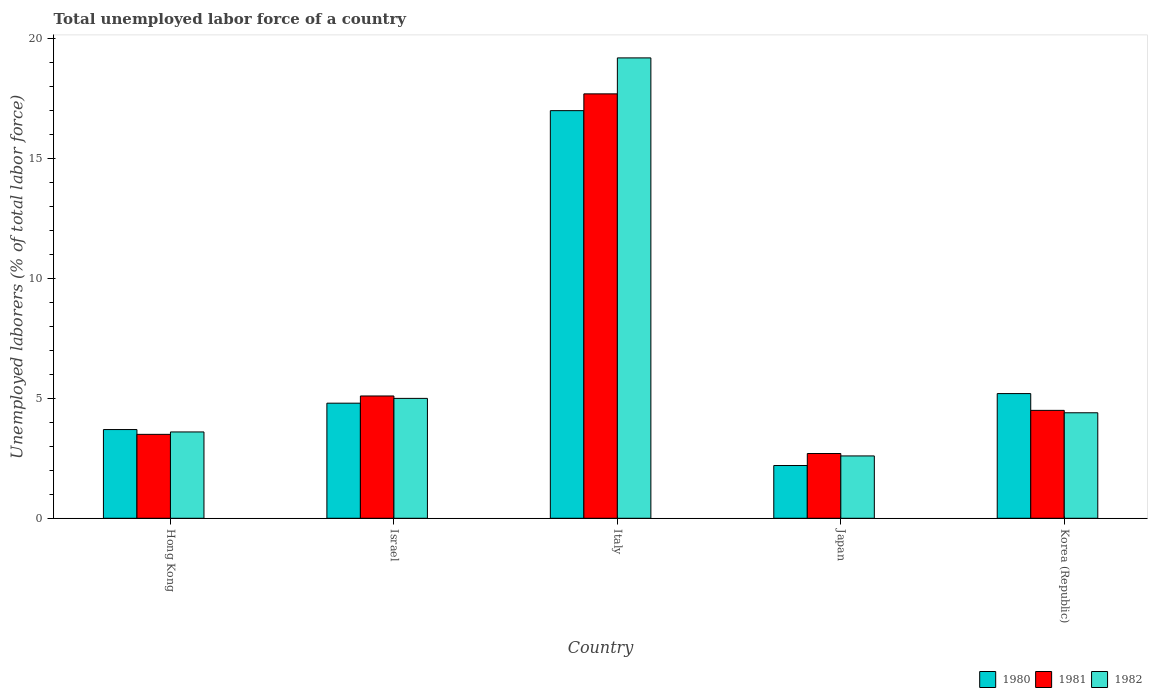How many bars are there on the 4th tick from the left?
Offer a terse response. 3. How many bars are there on the 3rd tick from the right?
Make the answer very short. 3. What is the label of the 2nd group of bars from the left?
Give a very brief answer. Israel. What is the total unemployed labor force in 1982 in Hong Kong?
Offer a very short reply. 3.6. Across all countries, what is the minimum total unemployed labor force in 1980?
Your answer should be very brief. 2.2. In which country was the total unemployed labor force in 1981 maximum?
Your response must be concise. Italy. In which country was the total unemployed labor force in 1980 minimum?
Ensure brevity in your answer.  Japan. What is the total total unemployed labor force in 1980 in the graph?
Give a very brief answer. 32.9. What is the difference between the total unemployed labor force in 1982 in Italy and that in Korea (Republic)?
Your answer should be compact. 14.8. What is the difference between the total unemployed labor force in 1982 in Japan and the total unemployed labor force in 1981 in Italy?
Provide a short and direct response. -15.1. What is the average total unemployed labor force in 1981 per country?
Offer a terse response. 6.7. What is the difference between the total unemployed labor force of/in 1982 and total unemployed labor force of/in 1980 in Israel?
Offer a very short reply. 0.2. In how many countries, is the total unemployed labor force in 1980 greater than 10 %?
Ensure brevity in your answer.  1. What is the ratio of the total unemployed labor force in 1980 in Italy to that in Korea (Republic)?
Offer a terse response. 3.27. Is the total unemployed labor force in 1982 in Japan less than that in Korea (Republic)?
Provide a short and direct response. Yes. Is the difference between the total unemployed labor force in 1982 in Japan and Korea (Republic) greater than the difference between the total unemployed labor force in 1980 in Japan and Korea (Republic)?
Give a very brief answer. Yes. What is the difference between the highest and the second highest total unemployed labor force in 1980?
Your response must be concise. 12.2. What is the difference between the highest and the lowest total unemployed labor force in 1981?
Make the answer very short. 15. In how many countries, is the total unemployed labor force in 1982 greater than the average total unemployed labor force in 1982 taken over all countries?
Offer a terse response. 1. Is it the case that in every country, the sum of the total unemployed labor force in 1981 and total unemployed labor force in 1980 is greater than the total unemployed labor force in 1982?
Your answer should be compact. Yes. Are all the bars in the graph horizontal?
Your answer should be compact. No. How many countries are there in the graph?
Make the answer very short. 5. Does the graph contain any zero values?
Provide a short and direct response. No. Does the graph contain grids?
Your answer should be very brief. No. Where does the legend appear in the graph?
Provide a short and direct response. Bottom right. What is the title of the graph?
Ensure brevity in your answer.  Total unemployed labor force of a country. What is the label or title of the X-axis?
Offer a terse response. Country. What is the label or title of the Y-axis?
Provide a succinct answer. Unemployed laborers (% of total labor force). What is the Unemployed laborers (% of total labor force) of 1980 in Hong Kong?
Ensure brevity in your answer.  3.7. What is the Unemployed laborers (% of total labor force) in 1981 in Hong Kong?
Provide a short and direct response. 3.5. What is the Unemployed laborers (% of total labor force) of 1982 in Hong Kong?
Your answer should be compact. 3.6. What is the Unemployed laborers (% of total labor force) in 1980 in Israel?
Offer a terse response. 4.8. What is the Unemployed laborers (% of total labor force) in 1981 in Israel?
Your answer should be compact. 5.1. What is the Unemployed laborers (% of total labor force) of 1980 in Italy?
Provide a short and direct response. 17. What is the Unemployed laborers (% of total labor force) in 1981 in Italy?
Provide a short and direct response. 17.7. What is the Unemployed laborers (% of total labor force) in 1982 in Italy?
Your response must be concise. 19.2. What is the Unemployed laborers (% of total labor force) in 1980 in Japan?
Provide a short and direct response. 2.2. What is the Unemployed laborers (% of total labor force) of 1981 in Japan?
Your response must be concise. 2.7. What is the Unemployed laborers (% of total labor force) in 1982 in Japan?
Make the answer very short. 2.6. What is the Unemployed laborers (% of total labor force) of 1980 in Korea (Republic)?
Offer a terse response. 5.2. What is the Unemployed laborers (% of total labor force) of 1982 in Korea (Republic)?
Your response must be concise. 4.4. Across all countries, what is the maximum Unemployed laborers (% of total labor force) in 1981?
Keep it short and to the point. 17.7. Across all countries, what is the maximum Unemployed laborers (% of total labor force) in 1982?
Provide a short and direct response. 19.2. Across all countries, what is the minimum Unemployed laborers (% of total labor force) of 1980?
Provide a succinct answer. 2.2. Across all countries, what is the minimum Unemployed laborers (% of total labor force) in 1981?
Keep it short and to the point. 2.7. Across all countries, what is the minimum Unemployed laborers (% of total labor force) of 1982?
Keep it short and to the point. 2.6. What is the total Unemployed laborers (% of total labor force) in 1980 in the graph?
Your answer should be compact. 32.9. What is the total Unemployed laborers (% of total labor force) of 1981 in the graph?
Keep it short and to the point. 33.5. What is the total Unemployed laborers (% of total labor force) of 1982 in the graph?
Make the answer very short. 34.8. What is the difference between the Unemployed laborers (% of total labor force) in 1981 in Hong Kong and that in Israel?
Give a very brief answer. -1.6. What is the difference between the Unemployed laborers (% of total labor force) of 1982 in Hong Kong and that in Israel?
Provide a succinct answer. -1.4. What is the difference between the Unemployed laborers (% of total labor force) in 1980 in Hong Kong and that in Italy?
Give a very brief answer. -13.3. What is the difference between the Unemployed laborers (% of total labor force) of 1981 in Hong Kong and that in Italy?
Your response must be concise. -14.2. What is the difference between the Unemployed laborers (% of total labor force) in 1982 in Hong Kong and that in Italy?
Your response must be concise. -15.6. What is the difference between the Unemployed laborers (% of total labor force) in 1980 in Hong Kong and that in Japan?
Your response must be concise. 1.5. What is the difference between the Unemployed laborers (% of total labor force) in 1982 in Hong Kong and that in Japan?
Offer a very short reply. 1. What is the difference between the Unemployed laborers (% of total labor force) of 1981 in Hong Kong and that in Korea (Republic)?
Provide a short and direct response. -1. What is the difference between the Unemployed laborers (% of total labor force) in 1980 in Israel and that in Italy?
Offer a very short reply. -12.2. What is the difference between the Unemployed laborers (% of total labor force) in 1982 in Israel and that in Italy?
Your answer should be very brief. -14.2. What is the difference between the Unemployed laborers (% of total labor force) of 1981 in Israel and that in Japan?
Your answer should be very brief. 2.4. What is the difference between the Unemployed laborers (% of total labor force) of 1981 in Israel and that in Korea (Republic)?
Offer a terse response. 0.6. What is the difference between the Unemployed laborers (% of total labor force) of 1982 in Italy and that in Japan?
Make the answer very short. 16.6. What is the difference between the Unemployed laborers (% of total labor force) of 1981 in Italy and that in Korea (Republic)?
Provide a short and direct response. 13.2. What is the difference between the Unemployed laborers (% of total labor force) of 1982 in Italy and that in Korea (Republic)?
Provide a succinct answer. 14.8. What is the difference between the Unemployed laborers (% of total labor force) in 1982 in Japan and that in Korea (Republic)?
Offer a terse response. -1.8. What is the difference between the Unemployed laborers (% of total labor force) of 1980 in Hong Kong and the Unemployed laborers (% of total labor force) of 1982 in Italy?
Give a very brief answer. -15.5. What is the difference between the Unemployed laborers (% of total labor force) of 1981 in Hong Kong and the Unemployed laborers (% of total labor force) of 1982 in Italy?
Your answer should be compact. -15.7. What is the difference between the Unemployed laborers (% of total labor force) of 1980 in Hong Kong and the Unemployed laborers (% of total labor force) of 1982 in Japan?
Ensure brevity in your answer.  1.1. What is the difference between the Unemployed laborers (% of total labor force) of 1981 in Hong Kong and the Unemployed laborers (% of total labor force) of 1982 in Japan?
Your answer should be compact. 0.9. What is the difference between the Unemployed laborers (% of total labor force) in 1981 in Hong Kong and the Unemployed laborers (% of total labor force) in 1982 in Korea (Republic)?
Your response must be concise. -0.9. What is the difference between the Unemployed laborers (% of total labor force) of 1980 in Israel and the Unemployed laborers (% of total labor force) of 1982 in Italy?
Ensure brevity in your answer.  -14.4. What is the difference between the Unemployed laborers (% of total labor force) in 1981 in Israel and the Unemployed laborers (% of total labor force) in 1982 in Italy?
Ensure brevity in your answer.  -14.1. What is the difference between the Unemployed laborers (% of total labor force) of 1980 in Israel and the Unemployed laborers (% of total labor force) of 1981 in Japan?
Give a very brief answer. 2.1. What is the difference between the Unemployed laborers (% of total labor force) of 1980 in Israel and the Unemployed laborers (% of total labor force) of 1982 in Japan?
Provide a succinct answer. 2.2. What is the difference between the Unemployed laborers (% of total labor force) in 1981 in Israel and the Unemployed laborers (% of total labor force) in 1982 in Japan?
Give a very brief answer. 2.5. What is the difference between the Unemployed laborers (% of total labor force) in 1980 in Israel and the Unemployed laborers (% of total labor force) in 1981 in Korea (Republic)?
Your answer should be very brief. 0.3. What is the difference between the Unemployed laborers (% of total labor force) in 1980 in Israel and the Unemployed laborers (% of total labor force) in 1982 in Korea (Republic)?
Make the answer very short. 0.4. What is the difference between the Unemployed laborers (% of total labor force) of 1980 in Italy and the Unemployed laborers (% of total labor force) of 1982 in Japan?
Offer a very short reply. 14.4. What is the difference between the Unemployed laborers (% of total labor force) in 1981 in Italy and the Unemployed laborers (% of total labor force) in 1982 in Japan?
Your response must be concise. 15.1. What is the difference between the Unemployed laborers (% of total labor force) in 1980 in Italy and the Unemployed laborers (% of total labor force) in 1981 in Korea (Republic)?
Provide a short and direct response. 12.5. What is the difference between the Unemployed laborers (% of total labor force) of 1980 in Japan and the Unemployed laborers (% of total labor force) of 1982 in Korea (Republic)?
Keep it short and to the point. -2.2. What is the average Unemployed laborers (% of total labor force) of 1980 per country?
Provide a short and direct response. 6.58. What is the average Unemployed laborers (% of total labor force) in 1981 per country?
Your answer should be very brief. 6.7. What is the average Unemployed laborers (% of total labor force) in 1982 per country?
Provide a short and direct response. 6.96. What is the difference between the Unemployed laborers (% of total labor force) in 1980 and Unemployed laborers (% of total labor force) in 1981 in Hong Kong?
Provide a succinct answer. 0.2. What is the difference between the Unemployed laborers (% of total labor force) in 1980 and Unemployed laborers (% of total labor force) in 1982 in Hong Kong?
Give a very brief answer. 0.1. What is the difference between the Unemployed laborers (% of total labor force) of 1980 and Unemployed laborers (% of total labor force) of 1981 in Israel?
Ensure brevity in your answer.  -0.3. What is the difference between the Unemployed laborers (% of total labor force) of 1980 and Unemployed laborers (% of total labor force) of 1982 in Israel?
Your answer should be compact. -0.2. What is the difference between the Unemployed laborers (% of total labor force) in 1981 and Unemployed laborers (% of total labor force) in 1982 in Israel?
Your answer should be very brief. 0.1. What is the difference between the Unemployed laborers (% of total labor force) of 1980 and Unemployed laborers (% of total labor force) of 1982 in Italy?
Provide a succinct answer. -2.2. What is the difference between the Unemployed laborers (% of total labor force) of 1981 and Unemployed laborers (% of total labor force) of 1982 in Italy?
Provide a short and direct response. -1.5. What is the difference between the Unemployed laborers (% of total labor force) of 1980 and Unemployed laborers (% of total labor force) of 1981 in Korea (Republic)?
Offer a very short reply. 0.7. What is the difference between the Unemployed laborers (% of total labor force) of 1980 and Unemployed laborers (% of total labor force) of 1982 in Korea (Republic)?
Keep it short and to the point. 0.8. What is the ratio of the Unemployed laborers (% of total labor force) of 1980 in Hong Kong to that in Israel?
Ensure brevity in your answer.  0.77. What is the ratio of the Unemployed laborers (% of total labor force) in 1981 in Hong Kong to that in Israel?
Your answer should be very brief. 0.69. What is the ratio of the Unemployed laborers (% of total labor force) in 1982 in Hong Kong to that in Israel?
Provide a short and direct response. 0.72. What is the ratio of the Unemployed laborers (% of total labor force) in 1980 in Hong Kong to that in Italy?
Offer a very short reply. 0.22. What is the ratio of the Unemployed laborers (% of total labor force) in 1981 in Hong Kong to that in Italy?
Offer a very short reply. 0.2. What is the ratio of the Unemployed laborers (% of total labor force) in 1982 in Hong Kong to that in Italy?
Your answer should be very brief. 0.19. What is the ratio of the Unemployed laborers (% of total labor force) of 1980 in Hong Kong to that in Japan?
Ensure brevity in your answer.  1.68. What is the ratio of the Unemployed laborers (% of total labor force) in 1981 in Hong Kong to that in Japan?
Ensure brevity in your answer.  1.3. What is the ratio of the Unemployed laborers (% of total labor force) in 1982 in Hong Kong to that in Japan?
Give a very brief answer. 1.38. What is the ratio of the Unemployed laborers (% of total labor force) of 1980 in Hong Kong to that in Korea (Republic)?
Make the answer very short. 0.71. What is the ratio of the Unemployed laborers (% of total labor force) of 1981 in Hong Kong to that in Korea (Republic)?
Your response must be concise. 0.78. What is the ratio of the Unemployed laborers (% of total labor force) in 1982 in Hong Kong to that in Korea (Republic)?
Give a very brief answer. 0.82. What is the ratio of the Unemployed laborers (% of total labor force) in 1980 in Israel to that in Italy?
Your answer should be compact. 0.28. What is the ratio of the Unemployed laborers (% of total labor force) of 1981 in Israel to that in Italy?
Offer a terse response. 0.29. What is the ratio of the Unemployed laborers (% of total labor force) of 1982 in Israel to that in Italy?
Your response must be concise. 0.26. What is the ratio of the Unemployed laborers (% of total labor force) of 1980 in Israel to that in Japan?
Your response must be concise. 2.18. What is the ratio of the Unemployed laborers (% of total labor force) of 1981 in Israel to that in Japan?
Your answer should be very brief. 1.89. What is the ratio of the Unemployed laborers (% of total labor force) in 1982 in Israel to that in Japan?
Provide a short and direct response. 1.92. What is the ratio of the Unemployed laborers (% of total labor force) of 1981 in Israel to that in Korea (Republic)?
Ensure brevity in your answer.  1.13. What is the ratio of the Unemployed laborers (% of total labor force) in 1982 in Israel to that in Korea (Republic)?
Provide a short and direct response. 1.14. What is the ratio of the Unemployed laborers (% of total labor force) of 1980 in Italy to that in Japan?
Provide a short and direct response. 7.73. What is the ratio of the Unemployed laborers (% of total labor force) of 1981 in Italy to that in Japan?
Make the answer very short. 6.56. What is the ratio of the Unemployed laborers (% of total labor force) in 1982 in Italy to that in Japan?
Your answer should be very brief. 7.38. What is the ratio of the Unemployed laborers (% of total labor force) of 1980 in Italy to that in Korea (Republic)?
Your answer should be very brief. 3.27. What is the ratio of the Unemployed laborers (% of total labor force) in 1981 in Italy to that in Korea (Republic)?
Give a very brief answer. 3.93. What is the ratio of the Unemployed laborers (% of total labor force) of 1982 in Italy to that in Korea (Republic)?
Offer a terse response. 4.36. What is the ratio of the Unemployed laborers (% of total labor force) of 1980 in Japan to that in Korea (Republic)?
Your answer should be compact. 0.42. What is the ratio of the Unemployed laborers (% of total labor force) in 1982 in Japan to that in Korea (Republic)?
Keep it short and to the point. 0.59. What is the difference between the highest and the second highest Unemployed laborers (% of total labor force) of 1981?
Offer a very short reply. 12.6. What is the difference between the highest and the lowest Unemployed laborers (% of total labor force) in 1981?
Ensure brevity in your answer.  15. 